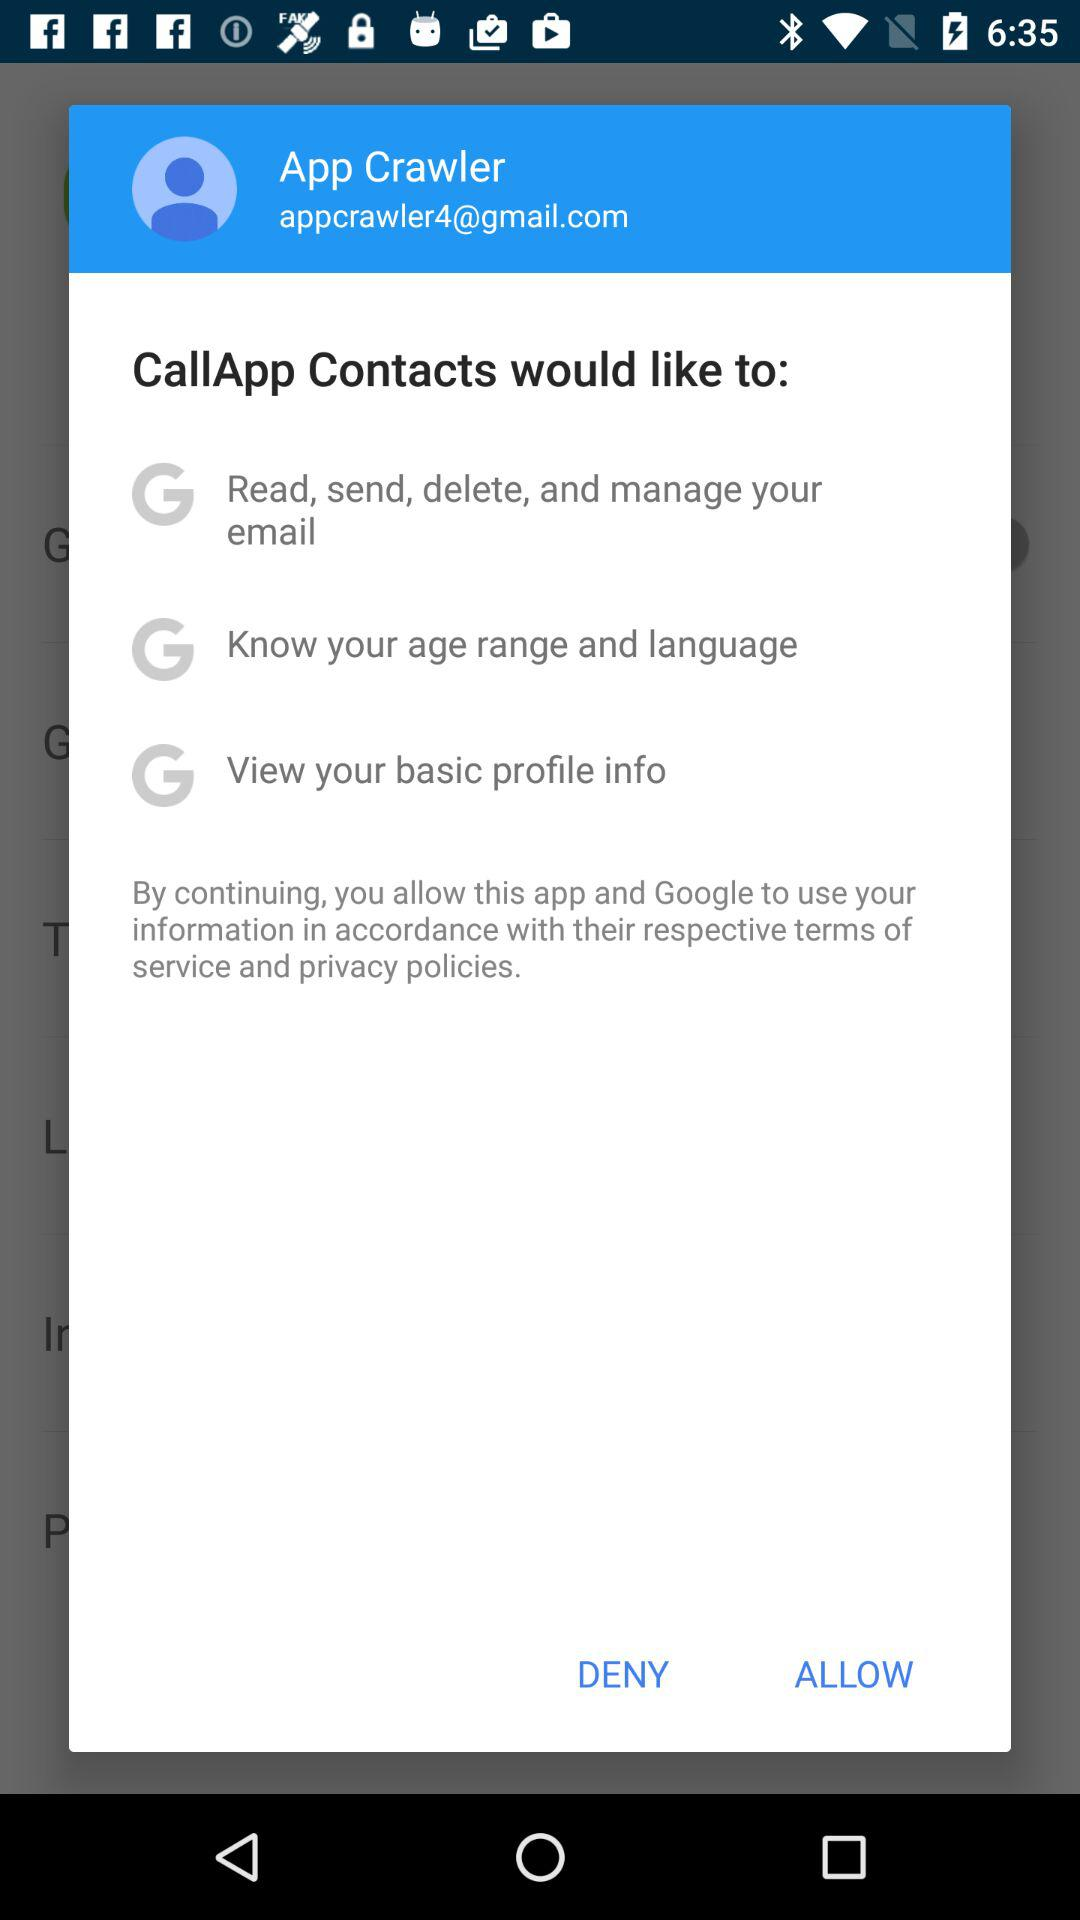How many permissions does CallApp Contacts want?
Answer the question using a single word or phrase. 3 